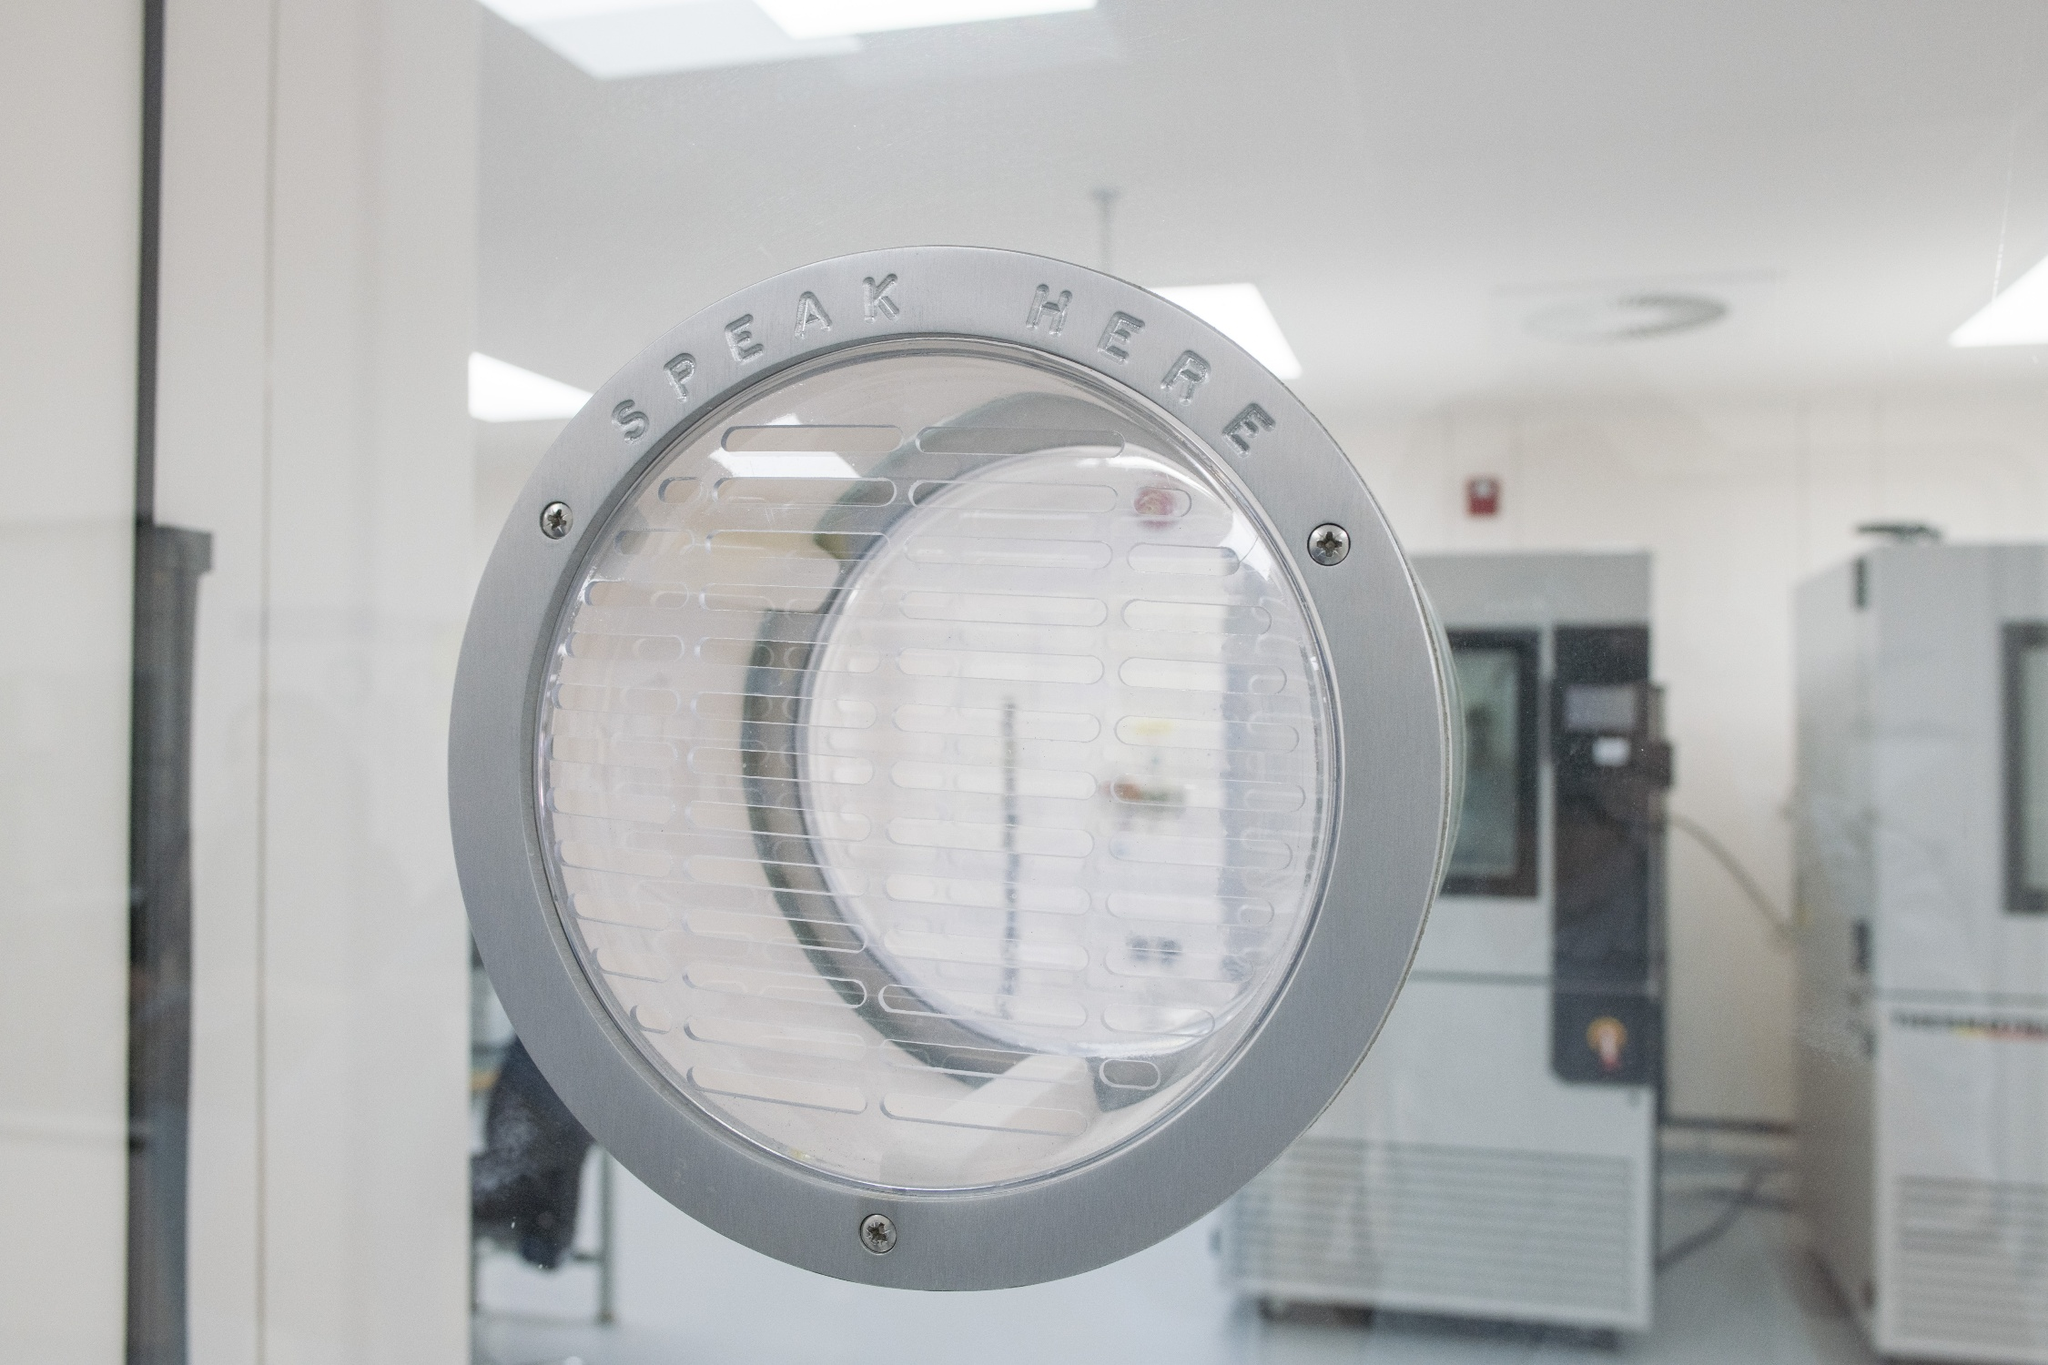What purpose do you think this intercom speaker serves in its setting? This intercom speaker is likely used for communication purposes in a professional or institutional setting, such as a laboratory, cleanroom, or secure facility. It allows individuals on either side of the barrier to speak and hear each other without direct physical contact, maintaining the integrity and security of the controlled environment. Is there anything unique or interesting about this setup? Yes, the setup is quite interesting because it highlights the importance of maintaining communication in environments where physical interaction might be restricted. The clear 'SPEAK HERE' instruction adds a user-friendly touch, ensuring that anyone using the intercom knows exactly where to direct their voice. This careful design consideration is crucial in settings where clarity and efficiency are paramount, such as in cleanrooms, research labs, or secure facilities. Can you describe a realistic scenario where this speaker might be used? In a cleanroom environment of a pharmaceutical research facility, scientists and technicians often need to communicate without breaking the sterile conditions. This intercom allows a technician inside the cleanroom to convey critical information to a colleague outside, such as updates on experiment progress or requests for additional supplies, without compromising the sterile environment. 